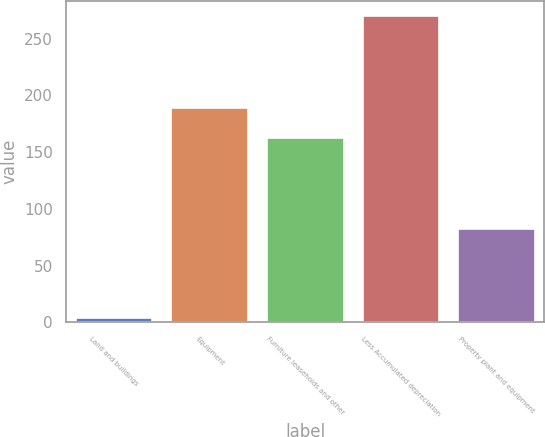Convert chart. <chart><loc_0><loc_0><loc_500><loc_500><bar_chart><fcel>Land and buildings<fcel>Equipment<fcel>Furniture leaseholds and other<fcel>Less Accumulated depreciation<fcel>Property plant and equipment<nl><fcel>3.5<fcel>188.96<fcel>162.3<fcel>270.1<fcel>82.6<nl></chart> 